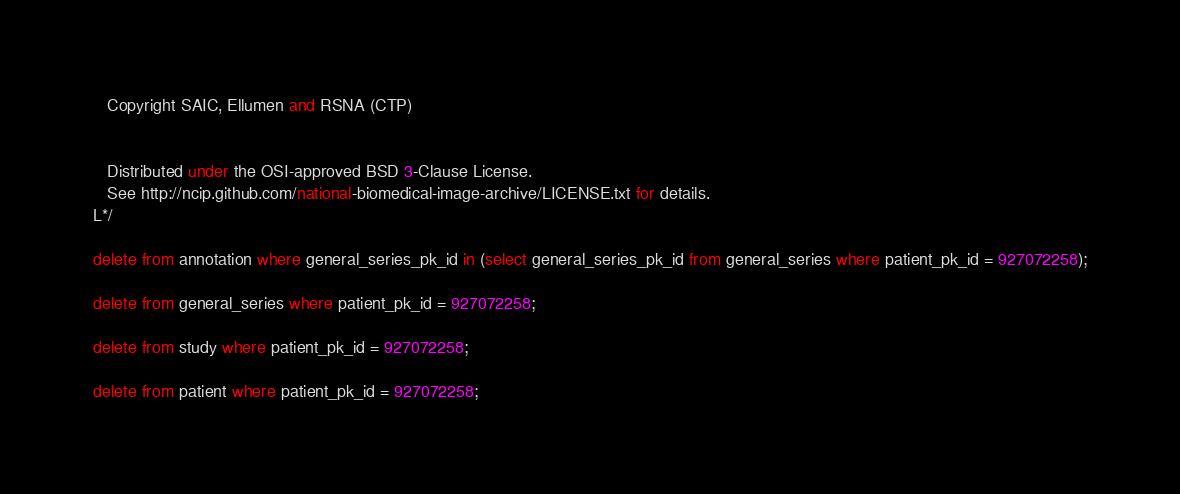Convert code to text. <code><loc_0><loc_0><loc_500><loc_500><_SQL_>   Copyright SAIC, Ellumen and RSNA (CTP)


   Distributed under the OSI-approved BSD 3-Clause License.
   See http://ncip.github.com/national-biomedical-image-archive/LICENSE.txt for details.
L*/

delete from annotation where general_series_pk_id in (select general_series_pk_id from general_series where patient_pk_id = 927072258);

delete from general_series where patient_pk_id = 927072258;  
  
delete from study where patient_pk_id = 927072258; 

delete from patient where patient_pk_id = 927072258;
</code> 